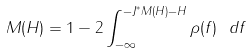Convert formula to latex. <formula><loc_0><loc_0><loc_500><loc_500>M ( H ) = 1 - 2 \int _ { - \infty } ^ { - J ^ { * } M ( H ) - H } \rho ( f ) \ d f</formula> 